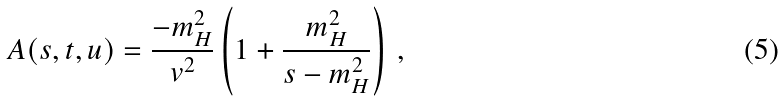Convert formula to latex. <formula><loc_0><loc_0><loc_500><loc_500>A ( s , t , u ) = \frac { - m _ { H } ^ { 2 } } { v ^ { 2 } } \left ( 1 + \frac { m _ { H } ^ { 2 } } { s - m _ { H } ^ { 2 } } \right ) \, ,</formula> 